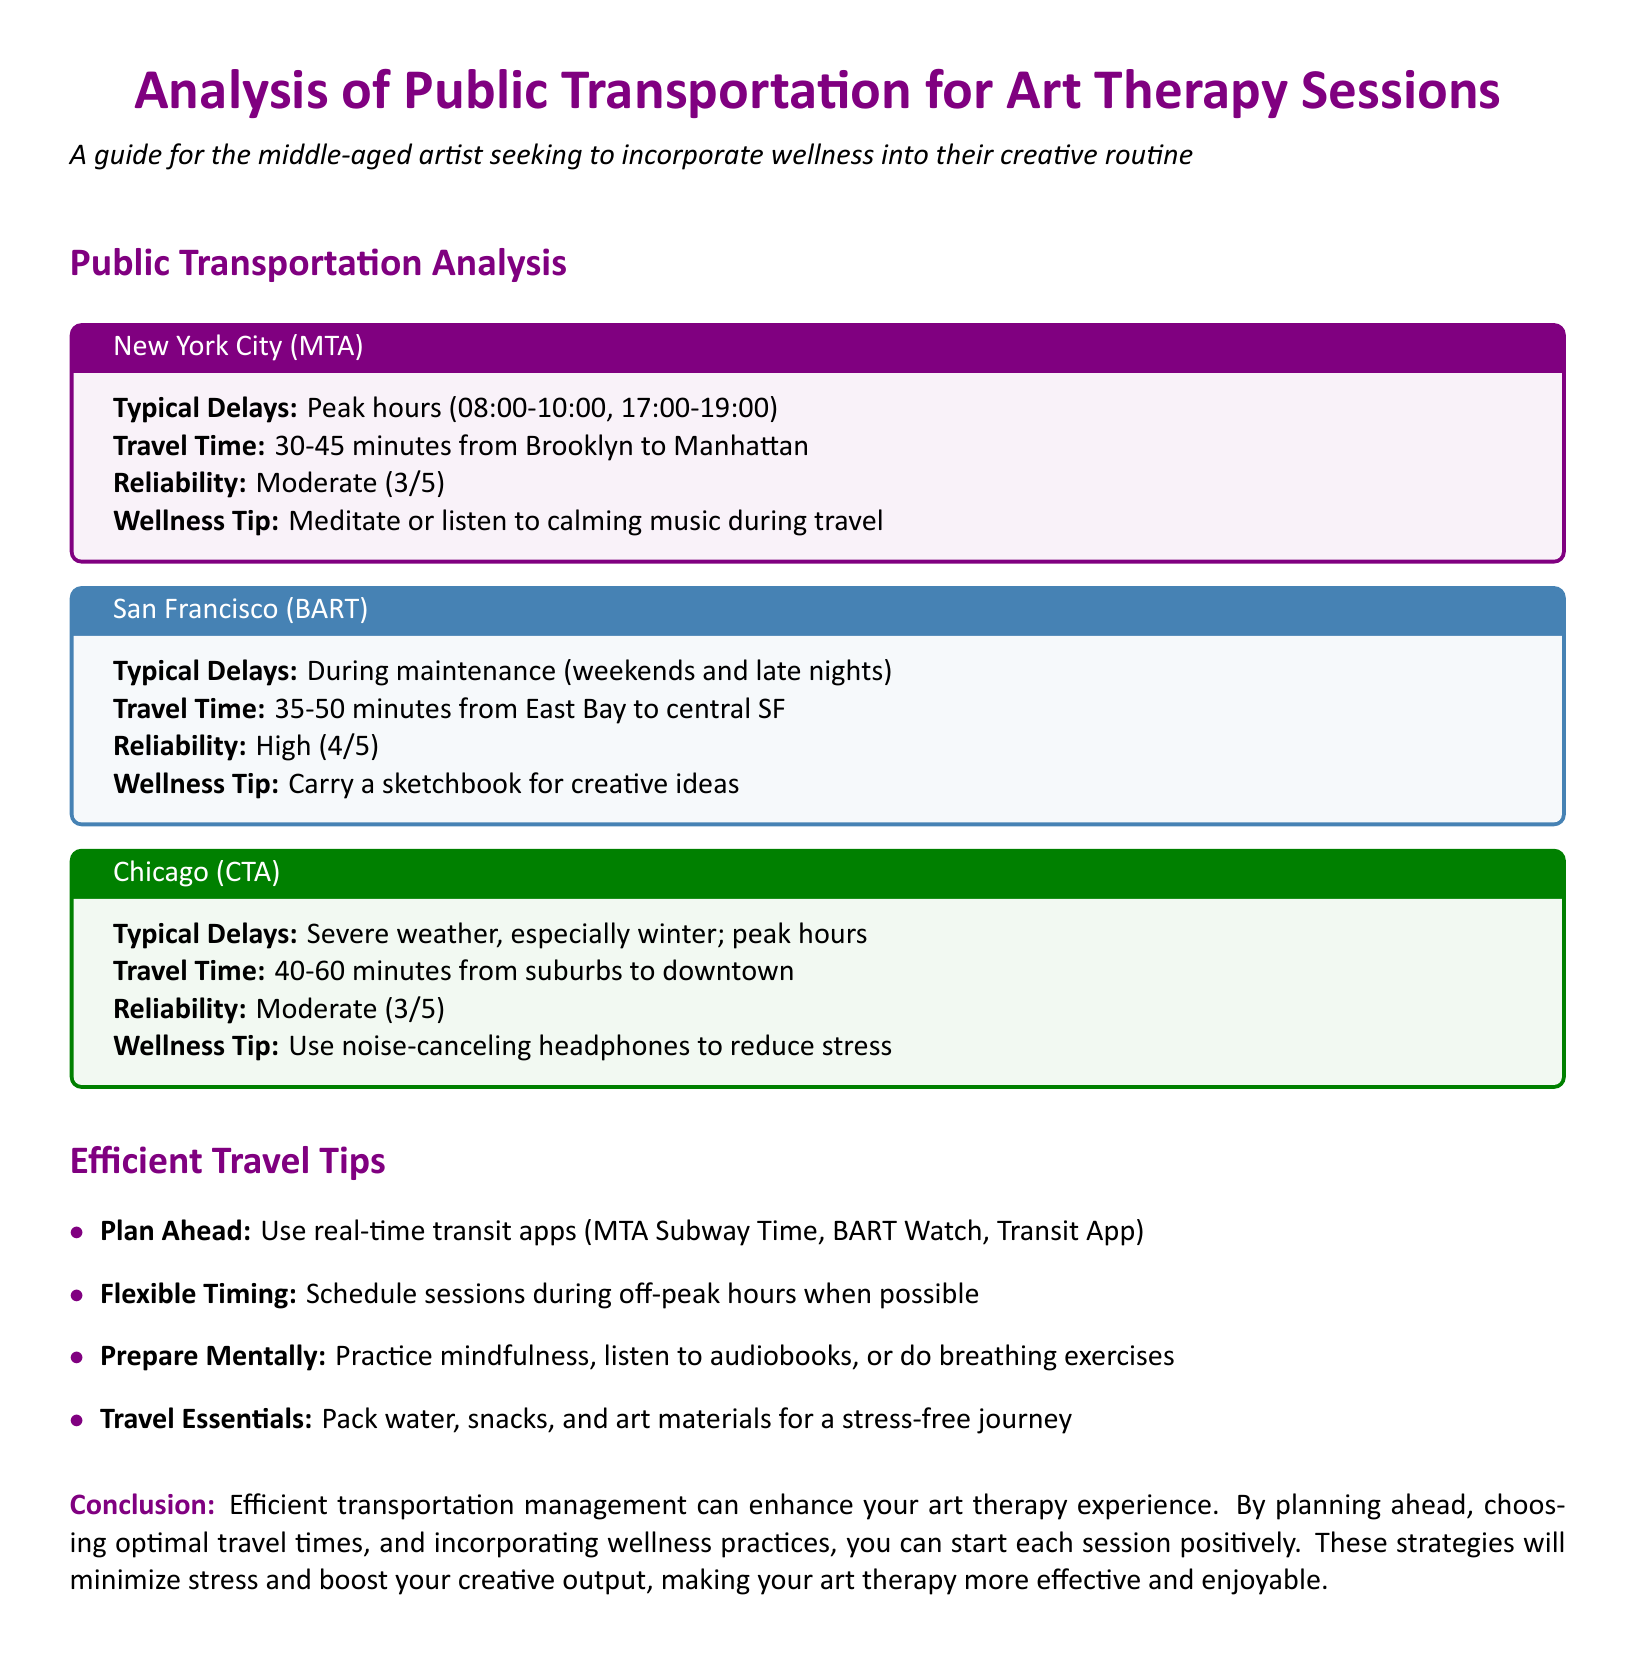What are the typical delays for NYC (MTA)? Typical delays for NYC (MTA) occur during peak hours, which are from 08:00 to 10:00 and 17:00 to 19:00.
Answer: Peak hours (08:00-10:00, 17:00-19:00) What is the reliability rating for San Francisco (BART)? The reliability rating for San Francisco (BART) is categorized as high on a scale of 1 to 5.
Answer: High (4/5) What wellness tip is suggested for Chicago (CTA)? The wellness tip suggested for Chicago (CTA) is to use noise-canceling headphones to reduce stress.
Answer: Use noise-canceling headphones What is the travel time from Brooklyn to Manhattan using NYC (MTA)? The travel time from Brooklyn to Manhattan using NYC (MTA) is specified in the document.
Answer: 30-45 minutes Which public transportation method has the highest reliability? San Francisco (BART) has the highest reliability rating compared to the other options listed.
Answer: San Francisco (BART) What is one of the efficient travel tips mentioned in the document? The document includes various efficient travel tips; one is to use real-time transit apps.
Answer: Use real-time transit apps During which time is it recommended to schedule sessions for efficient travel? The document suggests scheduling sessions during off-peak hours when possible for efficient travel.
Answer: Off-peak hours What impact does efficient transportation management have on art therapy experience? Efficient transportation management enhances the art therapy experience by minimizing stress and maximizing creativity.
Answer: Minimize stress, boost creativity 